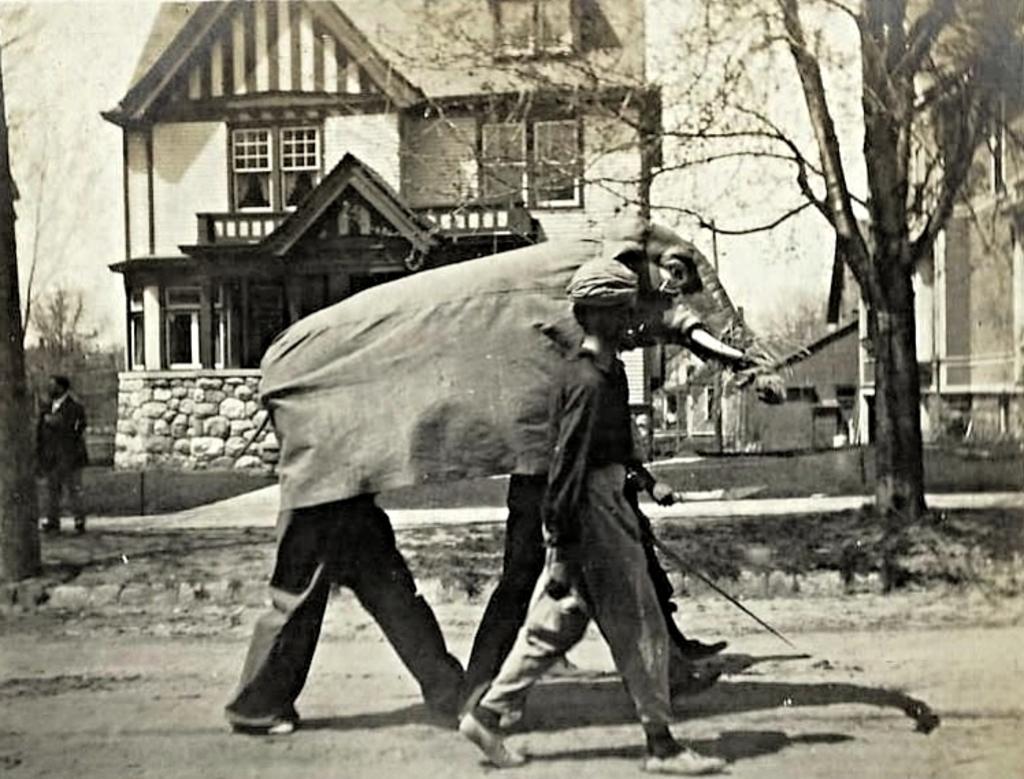Can you describe this image briefly? This is a black and white image. There is a building in the middle. There is a tree on the right side. There is a person standing on the left side. There are three persons walking in the middle. They are wearing the mask of an elephant. 